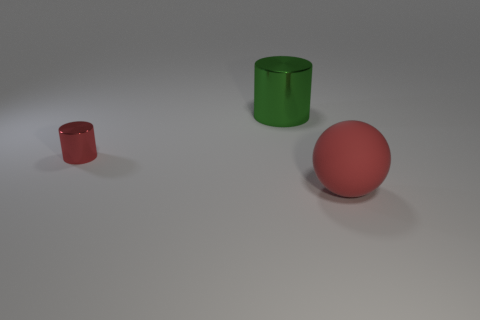Add 1 large matte balls. How many objects exist? 4 Subtract all balls. How many objects are left? 2 Add 3 cylinders. How many cylinders are left? 5 Add 2 tiny red metallic objects. How many tiny red metallic objects exist? 3 Subtract 0 blue cylinders. How many objects are left? 3 Subtract all large red objects. Subtract all large red things. How many objects are left? 1 